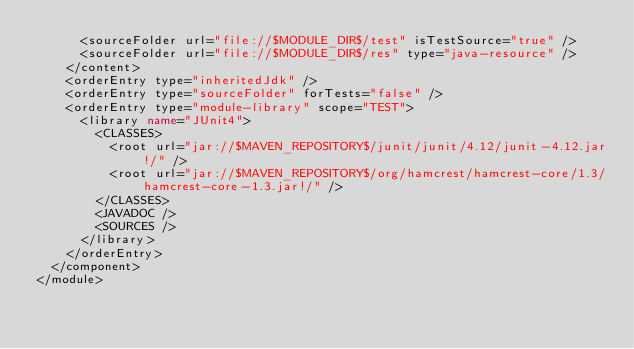Convert code to text. <code><loc_0><loc_0><loc_500><loc_500><_XML_>      <sourceFolder url="file://$MODULE_DIR$/test" isTestSource="true" />
      <sourceFolder url="file://$MODULE_DIR$/res" type="java-resource" />
    </content>
    <orderEntry type="inheritedJdk" />
    <orderEntry type="sourceFolder" forTests="false" />
    <orderEntry type="module-library" scope="TEST">
      <library name="JUnit4">
        <CLASSES>
          <root url="jar://$MAVEN_REPOSITORY$/junit/junit/4.12/junit-4.12.jar!/" />
          <root url="jar://$MAVEN_REPOSITORY$/org/hamcrest/hamcrest-core/1.3/hamcrest-core-1.3.jar!/" />
        </CLASSES>
        <JAVADOC />
        <SOURCES />
      </library>
    </orderEntry>
  </component>
</module></code> 